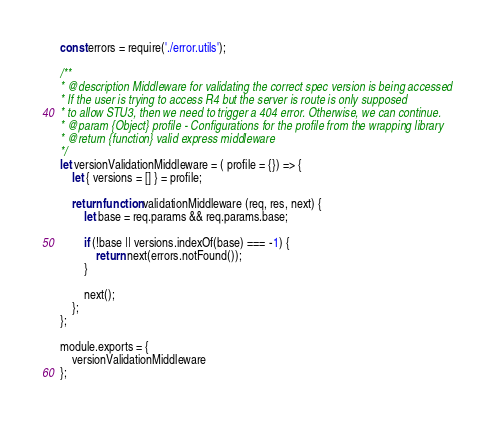Convert code to text. <code><loc_0><loc_0><loc_500><loc_500><_JavaScript_>const errors = require('./error.utils');

/**
* @description Middleware for validating the correct spec version is being accessed
* If the user is trying to access R4 but the server is route is only supposed
* to allow STU3, then we need to trigger a 404 error. Otherwise, we can continue.
* @param {Object} profile - Configurations for the profile from the wrapping library
* @return {function} valid express middleware
*/
let versionValidationMiddleware = ( profile = {}) => {
	let { versions = [] } = profile;

	return function validationMiddleware (req, res, next) {
		let base = req.params && req.params.base;

		if (!base || versions.indexOf(base) === -1) {
			return next(errors.notFound());
		}

		next();
	};
};

module.exports = {
	versionValidationMiddleware
};
</code> 